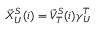Convert formula to latex. <formula><loc_0><loc_0><loc_500><loc_500>\begin{array} { r } { \vec { X } _ { U } ^ { S } ( i ) = \vec { V } _ { T } ^ { S } ( i ) \gamma _ { U } ^ { T } } \end{array}</formula> 